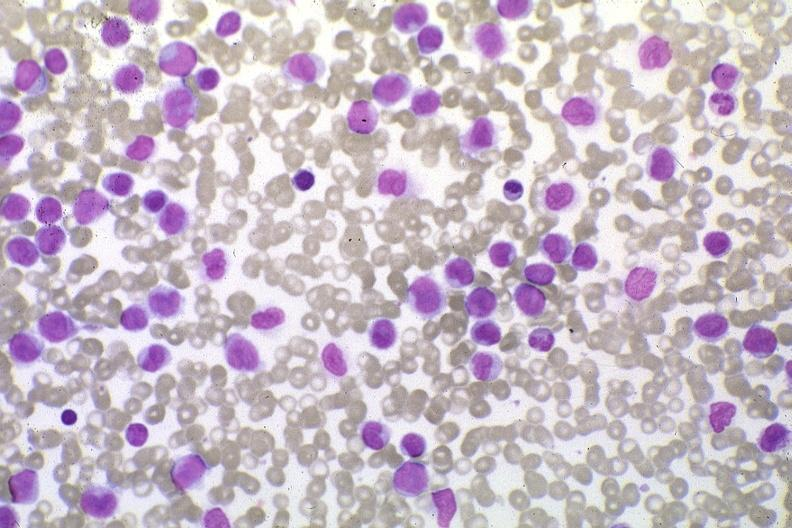what stain pleomorphic leukemic cells in peripheral blood prior to therapy?
Answer the question using a single word or phrase. Wrights 